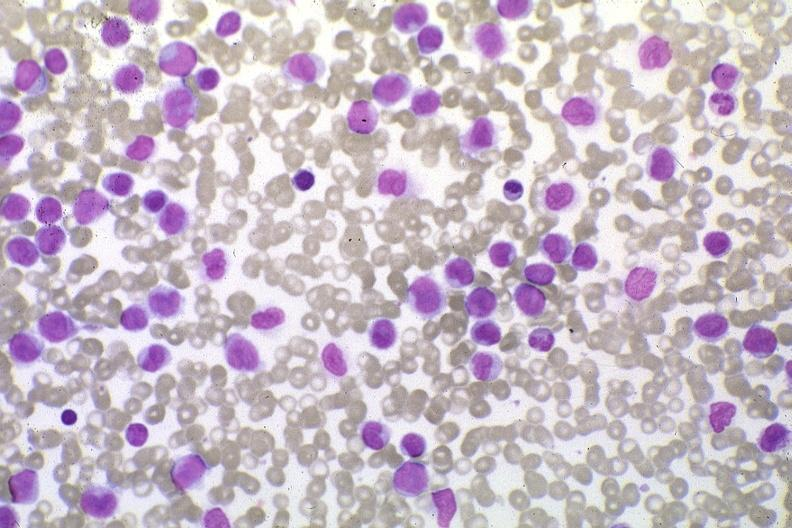what stain pleomorphic leukemic cells in peripheral blood prior to therapy?
Answer the question using a single word or phrase. Wrights 